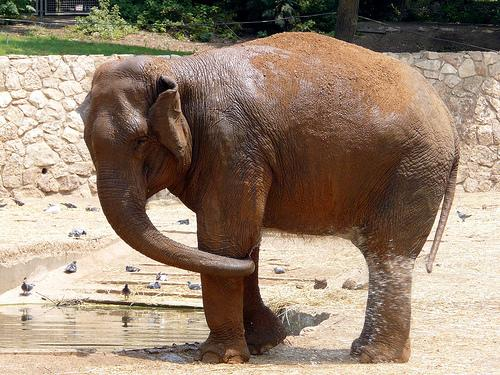In multiple-choice VQA task format, write a question about the elephant's environment and list three possible answers (label one as correct). c) White brick wall What is the main animal in the image and how does it appear in terms of color? The main animal is an elephant, which appears gray and brown in color. Can you suggest a suitable product advertisement based on this image? Promote a wildlife documentary series, showcasing the natural beauty and behaviors of elephants in their habitats. Identify an action described in the image that the elephant is doing with one of its body parts. The elephant's trunk is wrapping around its front leg. Describe the setting or environment where the elephant is placed. The elephant is in an enclosure surrounded by a rock wall, green grass, water, and bushes, and it is bright outside. List three things that can be found in the environment around the elephant. Water, green grass, and a large tan rock wall can be found around the elephant. For the visual entailment task, state whether the elephant appears to be outdoors or indoors. The elephant appears to be outdoors. List two objects that are near the elephant in the image. Water and a rock wall are two objects that are near the elephant in the image. 